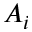Convert formula to latex. <formula><loc_0><loc_0><loc_500><loc_500>A _ { i }</formula> 